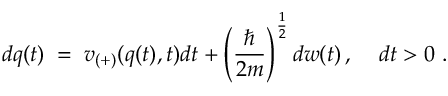<formula> <loc_0><loc_0><loc_500><loc_500>d q ( t ) \, = \, v _ { ( + ) } ( q ( t ) , t ) d t + \left ( \frac { } { 2 m } \right ) ^ { \frac { 1 } { 2 } } d w ( t ) \, , \, d t > 0 \, .</formula> 